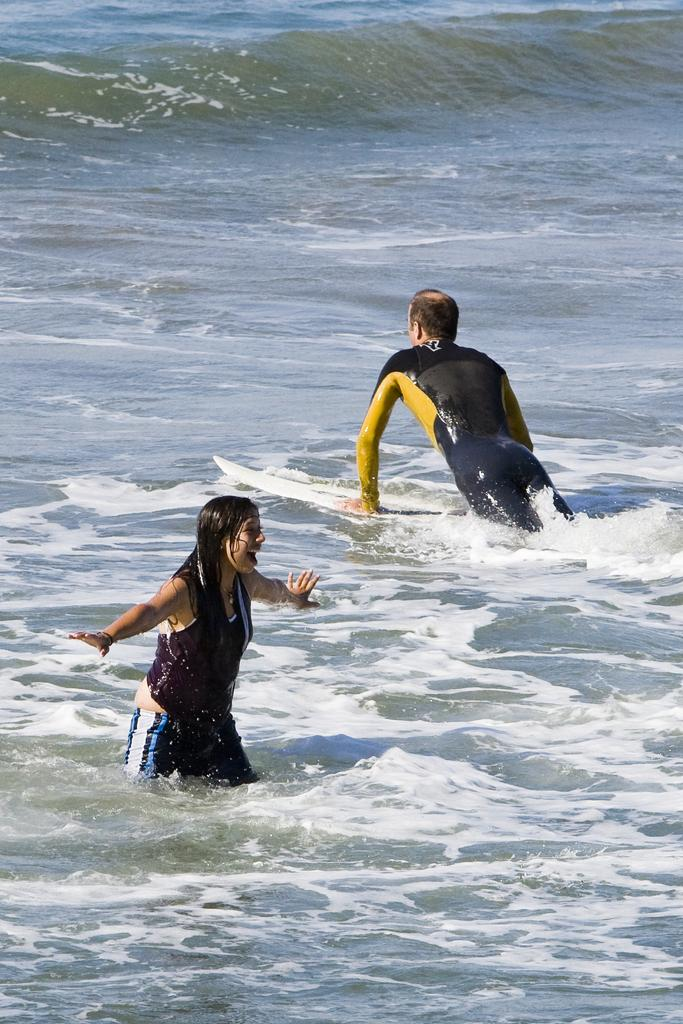How many people are in the image? There are two persons in the image. What are the two persons doing in the image? One person is standing in the water, and the other person is lying on a surfing board. What type of book is the person reading while lying on the surfing board? There is no book present in the image; the person is lying on a surfing board. 